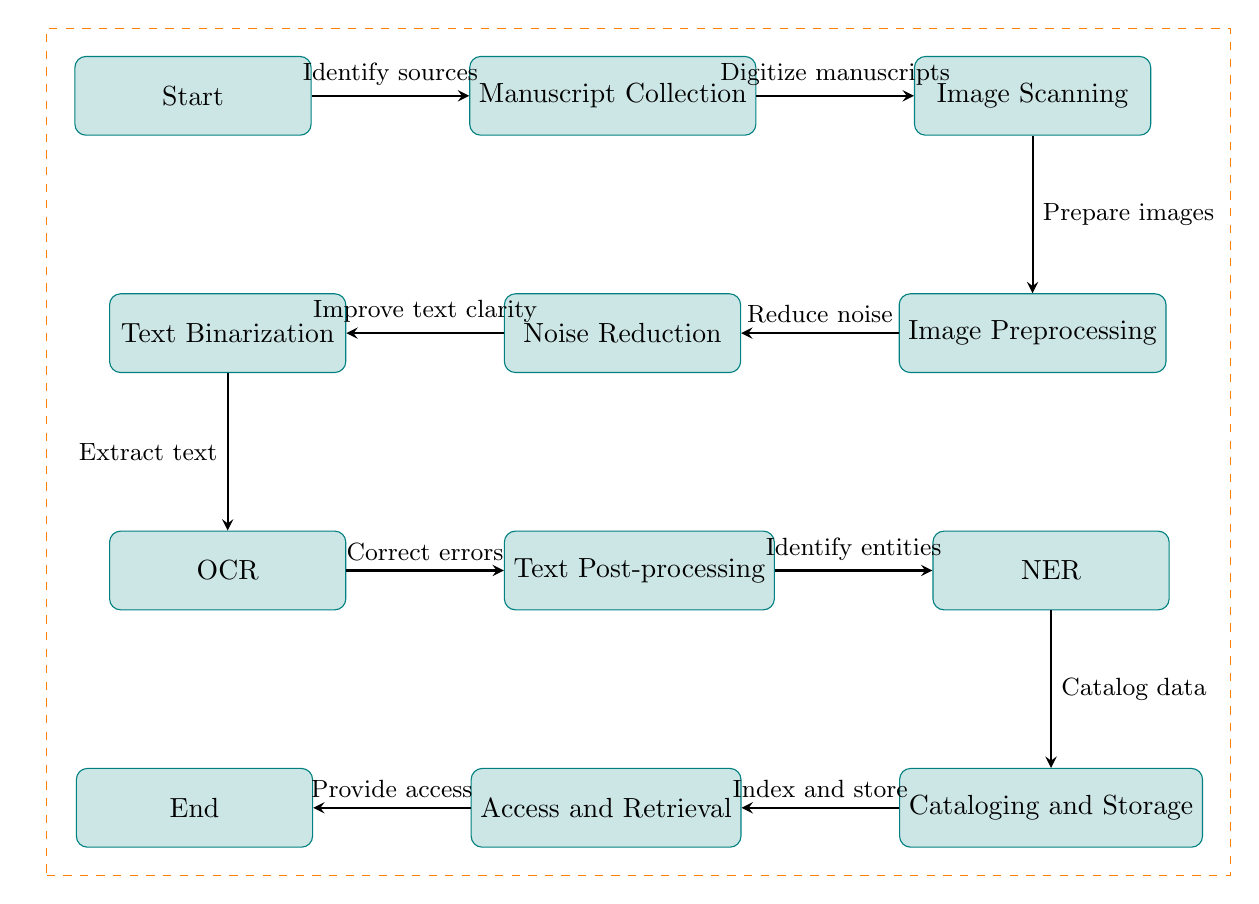What is the first step in the workflow? The first step is labeled "Start" in the diagram, indicating the beginning of the process.
Answer: Start How many processes are included in the workflow? There are 10 distinct processes represented in the diagram that carry out different tasks in the digitization and OCR workflow.
Answer: 10 What comes directly after the "Manuscript Collection" step? The diagram shows that after "Manuscript Collection," the next step is "Image Scanning," which is directly to the right of the collection.
Answer: Image Scanning What process follows "Image Preprocessing"? The next step after "Image Preprocessing" in the diagram is "OCR," which is below the preprocessing step, indicating it takes place after images are prepared.
Answer: OCR Which step involves improving text clarity? The diagram specifies that the "Text Binarization" process directly follows "Noise Reduction," where the main focus is on improving the clarity of the text.
Answer: Text Binarization What is the purpose of the "Post-processing" step? In the workflow, "Post-processing" serves the purpose of correcting errors identified during the OCR stage, aimed at refining the text recognition results.
Answer: Correct errors Which process includes the operation of identifying entities? The step titled "NER" (Named Entity Recognition) is responsible for identifying entities after the text has been processed, as depicted in the diagram.
Answer: NER What step does "Cataloging and Storage" depend on? "Cataloging and Storage" directly depends on the output from the "NER" step, as it follows immediately after it in the workflow and relies on its data for cataloging.
Answer: NER What action is taken in the "Access and Retrieval" step? The "Access and Retrieval" step involves providing access to the digitized and cataloged manuscripts, which is based on the index and store output from the previous step.
Answer: Provide access 